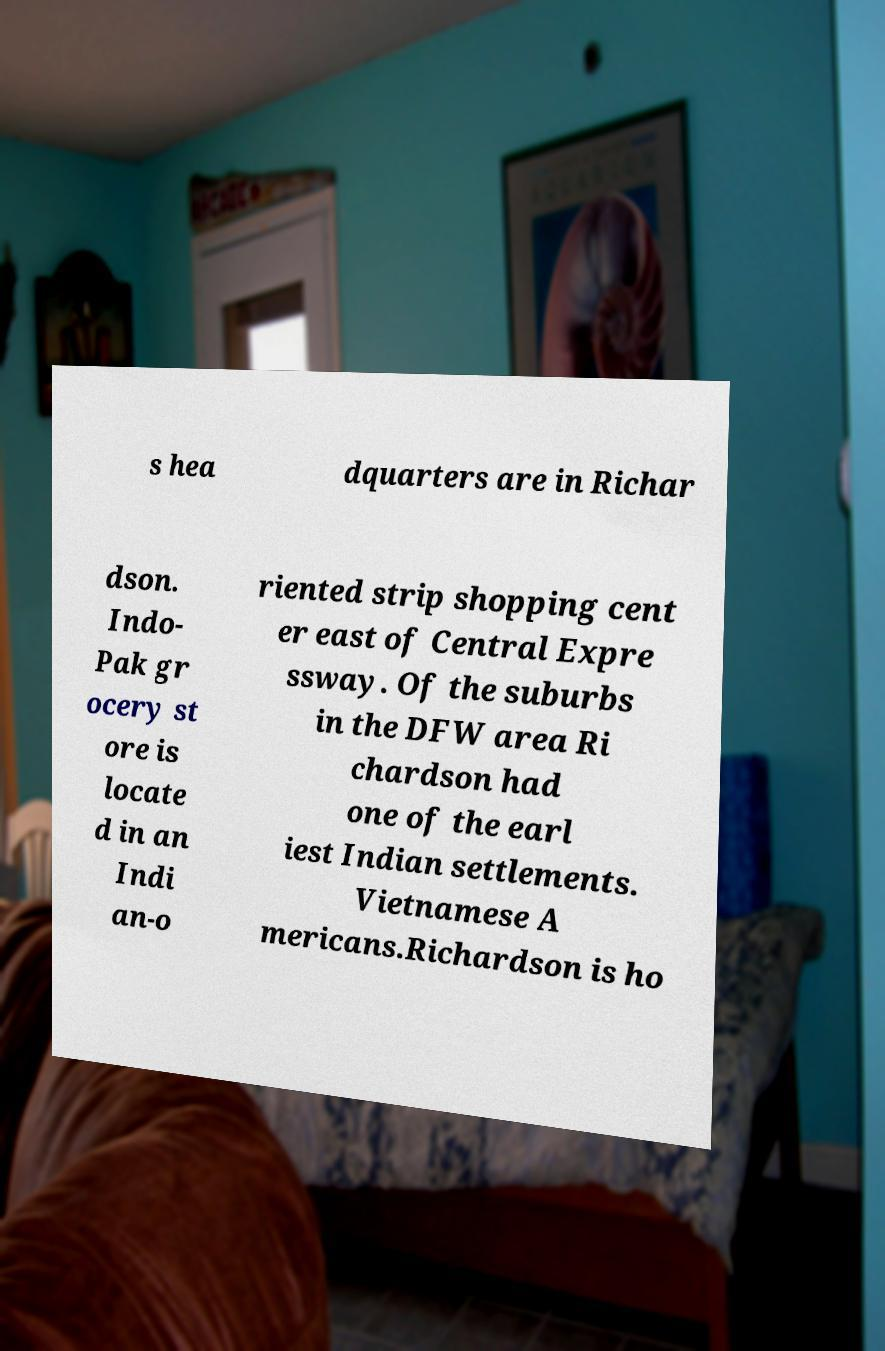I need the written content from this picture converted into text. Can you do that? s hea dquarters are in Richar dson. Indo- Pak gr ocery st ore is locate d in an Indi an-o riented strip shopping cent er east of Central Expre ssway. Of the suburbs in the DFW area Ri chardson had one of the earl iest Indian settlements. Vietnamese A mericans.Richardson is ho 